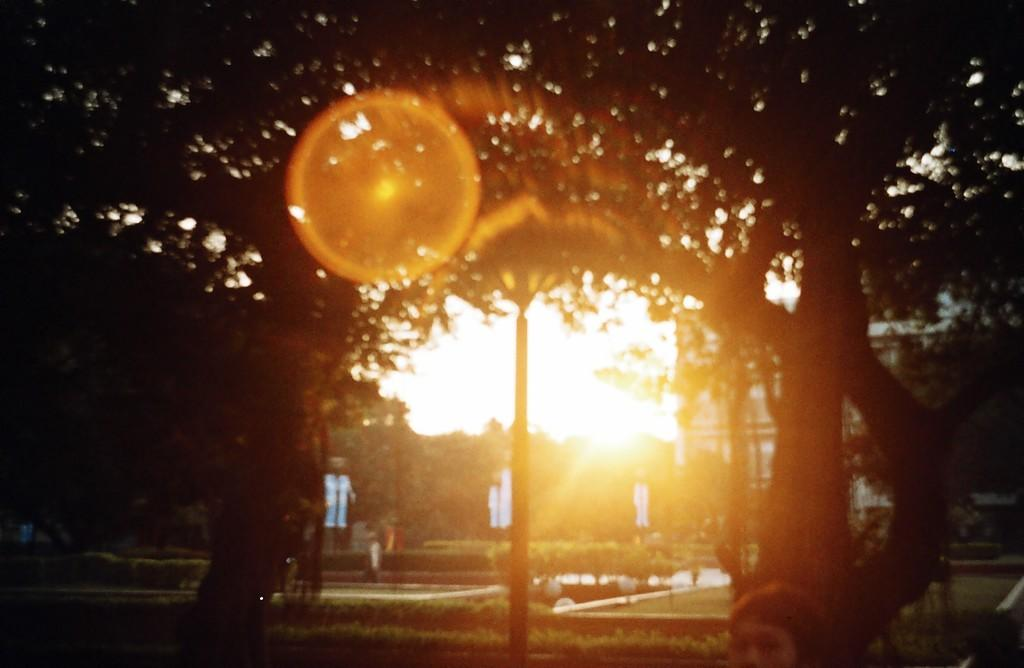What type of vegetation is present in the image? There are trees and plants in the image. Can you describe the pole at the bottom of the image? Yes, there is a pole at the bottom of the image. Where is the crib located in the image? There is no crib present in the image. What type of sponge can be seen in the image? There is no sponge present in the image. 